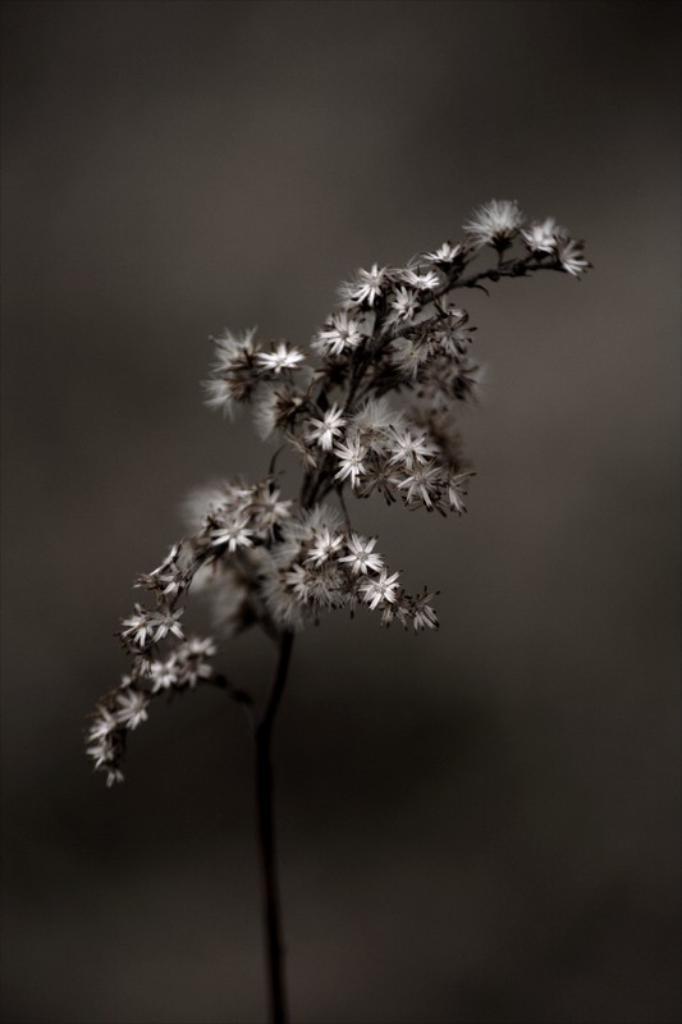Could you give a brief overview of what you see in this image? In this image there are flowers on a plant. The background is blurry. The image is black and white. 